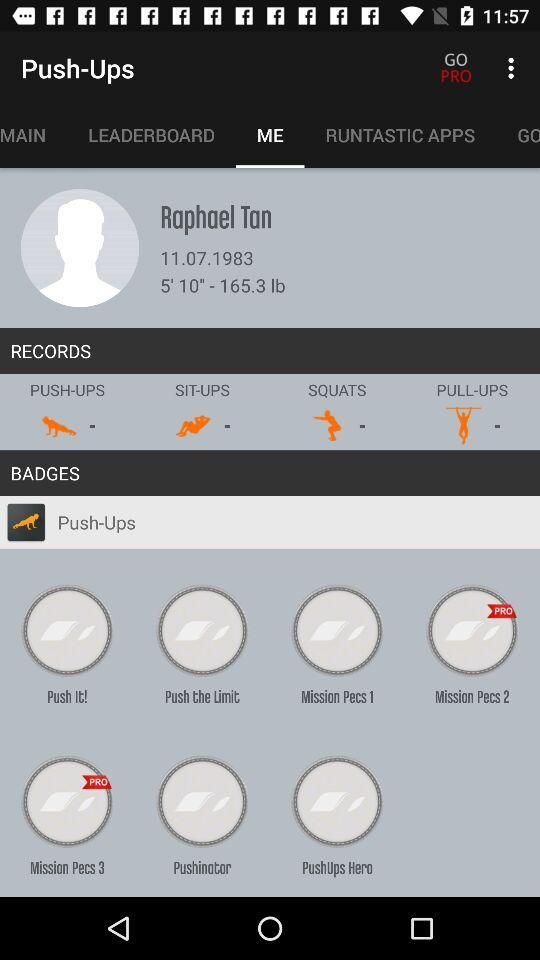What are the available exercises in "RECORDS"? The available exercises are push-ups, sit-ups, squats and pull-ups. 